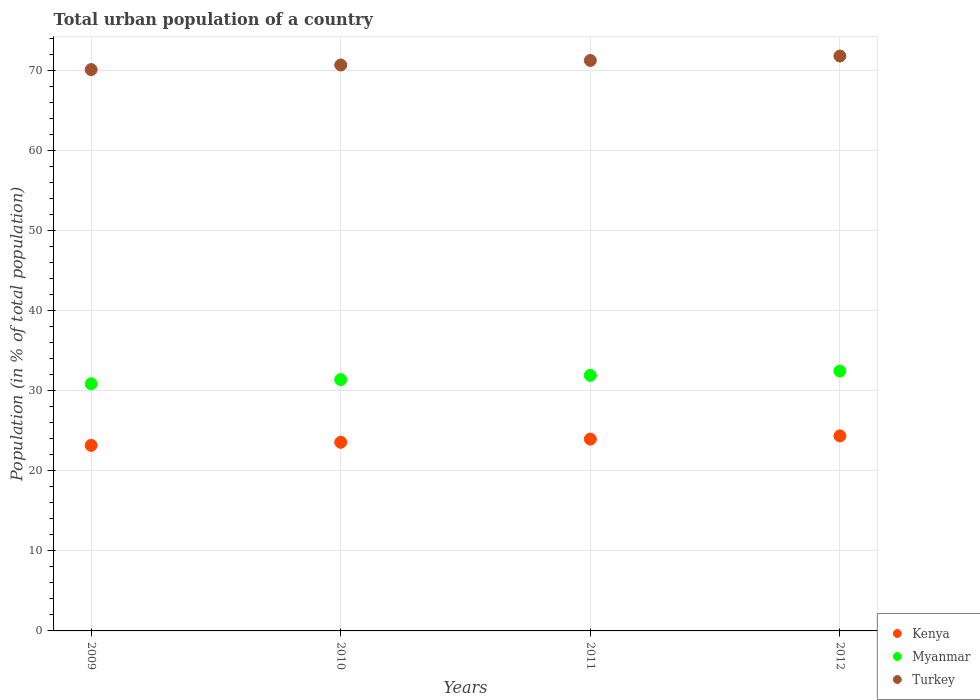How many different coloured dotlines are there?
Your answer should be compact. 3. What is the urban population in Kenya in 2010?
Keep it short and to the point. 23.57. Across all years, what is the maximum urban population in Turkey?
Your answer should be compact. 71.83. Across all years, what is the minimum urban population in Myanmar?
Your answer should be compact. 30.88. In which year was the urban population in Myanmar maximum?
Your answer should be very brief. 2012. In which year was the urban population in Myanmar minimum?
Offer a very short reply. 2009. What is the total urban population in Turkey in the graph?
Your answer should be very brief. 283.97. What is the difference between the urban population in Turkey in 2010 and that in 2011?
Give a very brief answer. -0.57. What is the difference between the urban population in Myanmar in 2009 and the urban population in Turkey in 2012?
Provide a short and direct response. -40.95. What is the average urban population in Kenya per year?
Offer a very short reply. 23.77. In the year 2010, what is the difference between the urban population in Myanmar and urban population in Turkey?
Offer a terse response. -39.31. In how many years, is the urban population in Kenya greater than 62 %?
Provide a short and direct response. 0. What is the ratio of the urban population in Turkey in 2010 to that in 2011?
Provide a succinct answer. 0.99. What is the difference between the highest and the second highest urban population in Turkey?
Ensure brevity in your answer.  0.55. What is the difference between the highest and the lowest urban population in Turkey?
Provide a short and direct response. 1.69. Is it the case that in every year, the sum of the urban population in Kenya and urban population in Turkey  is greater than the urban population in Myanmar?
Give a very brief answer. Yes. Does the urban population in Myanmar monotonically increase over the years?
Provide a short and direct response. Yes. How many years are there in the graph?
Make the answer very short. 4. What is the difference between two consecutive major ticks on the Y-axis?
Provide a succinct answer. 10. Are the values on the major ticks of Y-axis written in scientific E-notation?
Give a very brief answer. No. Does the graph contain any zero values?
Offer a terse response. No. How many legend labels are there?
Make the answer very short. 3. What is the title of the graph?
Offer a very short reply. Total urban population of a country. Does "Djibouti" appear as one of the legend labels in the graph?
Your answer should be compact. No. What is the label or title of the X-axis?
Your answer should be compact. Years. What is the label or title of the Y-axis?
Your response must be concise. Population (in % of total population). What is the Population (in % of total population) of Kenya in 2009?
Provide a succinct answer. 23.18. What is the Population (in % of total population) in Myanmar in 2009?
Offer a terse response. 30.88. What is the Population (in % of total population) in Turkey in 2009?
Your response must be concise. 70.14. What is the Population (in % of total population) of Kenya in 2010?
Provide a succinct answer. 23.57. What is the Population (in % of total population) in Myanmar in 2010?
Offer a very short reply. 31.41. What is the Population (in % of total population) in Turkey in 2010?
Keep it short and to the point. 70.72. What is the Population (in % of total population) in Kenya in 2011?
Give a very brief answer. 23.97. What is the Population (in % of total population) in Myanmar in 2011?
Make the answer very short. 31.93. What is the Population (in % of total population) in Turkey in 2011?
Make the answer very short. 71.28. What is the Population (in % of total population) in Kenya in 2012?
Your answer should be compact. 24.37. What is the Population (in % of total population) in Myanmar in 2012?
Provide a short and direct response. 32.47. What is the Population (in % of total population) of Turkey in 2012?
Your answer should be compact. 71.83. Across all years, what is the maximum Population (in % of total population) in Kenya?
Ensure brevity in your answer.  24.37. Across all years, what is the maximum Population (in % of total population) of Myanmar?
Give a very brief answer. 32.47. Across all years, what is the maximum Population (in % of total population) of Turkey?
Offer a very short reply. 71.83. Across all years, what is the minimum Population (in % of total population) of Kenya?
Provide a short and direct response. 23.18. Across all years, what is the minimum Population (in % of total population) in Myanmar?
Offer a terse response. 30.88. Across all years, what is the minimum Population (in % of total population) of Turkey?
Offer a terse response. 70.14. What is the total Population (in % of total population) of Kenya in the graph?
Offer a very short reply. 95.09. What is the total Population (in % of total population) in Myanmar in the graph?
Offer a terse response. 126.69. What is the total Population (in % of total population) of Turkey in the graph?
Provide a succinct answer. 283.97. What is the difference between the Population (in % of total population) of Kenya in 2009 and that in 2010?
Your answer should be very brief. -0.39. What is the difference between the Population (in % of total population) in Myanmar in 2009 and that in 2010?
Your answer should be compact. -0.52. What is the difference between the Population (in % of total population) of Turkey in 2009 and that in 2010?
Your response must be concise. -0.57. What is the difference between the Population (in % of total population) in Kenya in 2009 and that in 2011?
Give a very brief answer. -0.78. What is the difference between the Population (in % of total population) of Myanmar in 2009 and that in 2011?
Make the answer very short. -1.05. What is the difference between the Population (in % of total population) of Turkey in 2009 and that in 2011?
Keep it short and to the point. -1.14. What is the difference between the Population (in % of total population) in Kenya in 2009 and that in 2012?
Keep it short and to the point. -1.19. What is the difference between the Population (in % of total population) of Myanmar in 2009 and that in 2012?
Your answer should be compact. -1.59. What is the difference between the Population (in % of total population) in Turkey in 2009 and that in 2012?
Offer a terse response. -1.69. What is the difference between the Population (in % of total population) of Kenya in 2010 and that in 2011?
Offer a very short reply. -0.4. What is the difference between the Population (in % of total population) in Myanmar in 2010 and that in 2011?
Your answer should be very brief. -0.53. What is the difference between the Population (in % of total population) in Turkey in 2010 and that in 2011?
Make the answer very short. -0.57. What is the difference between the Population (in % of total population) in Kenya in 2010 and that in 2012?
Offer a very short reply. -0.8. What is the difference between the Population (in % of total population) of Myanmar in 2010 and that in 2012?
Offer a very short reply. -1.06. What is the difference between the Population (in % of total population) in Turkey in 2010 and that in 2012?
Provide a succinct answer. -1.12. What is the difference between the Population (in % of total population) of Kenya in 2011 and that in 2012?
Provide a short and direct response. -0.4. What is the difference between the Population (in % of total population) of Myanmar in 2011 and that in 2012?
Your response must be concise. -0.53. What is the difference between the Population (in % of total population) of Turkey in 2011 and that in 2012?
Ensure brevity in your answer.  -0.55. What is the difference between the Population (in % of total population) in Kenya in 2009 and the Population (in % of total population) in Myanmar in 2010?
Your answer should be very brief. -8.22. What is the difference between the Population (in % of total population) in Kenya in 2009 and the Population (in % of total population) in Turkey in 2010?
Your answer should be very brief. -47.53. What is the difference between the Population (in % of total population) of Myanmar in 2009 and the Population (in % of total population) of Turkey in 2010?
Provide a succinct answer. -39.83. What is the difference between the Population (in % of total population) in Kenya in 2009 and the Population (in % of total population) in Myanmar in 2011?
Keep it short and to the point. -8.75. What is the difference between the Population (in % of total population) of Kenya in 2009 and the Population (in % of total population) of Turkey in 2011?
Ensure brevity in your answer.  -48.1. What is the difference between the Population (in % of total population) of Myanmar in 2009 and the Population (in % of total population) of Turkey in 2011?
Ensure brevity in your answer.  -40.4. What is the difference between the Population (in % of total population) in Kenya in 2009 and the Population (in % of total population) in Myanmar in 2012?
Provide a short and direct response. -9.29. What is the difference between the Population (in % of total population) in Kenya in 2009 and the Population (in % of total population) in Turkey in 2012?
Make the answer very short. -48.65. What is the difference between the Population (in % of total population) of Myanmar in 2009 and the Population (in % of total population) of Turkey in 2012?
Offer a terse response. -40.95. What is the difference between the Population (in % of total population) of Kenya in 2010 and the Population (in % of total population) of Myanmar in 2011?
Give a very brief answer. -8.36. What is the difference between the Population (in % of total population) of Kenya in 2010 and the Population (in % of total population) of Turkey in 2011?
Make the answer very short. -47.71. What is the difference between the Population (in % of total population) in Myanmar in 2010 and the Population (in % of total population) in Turkey in 2011?
Your answer should be very brief. -39.88. What is the difference between the Population (in % of total population) in Kenya in 2010 and the Population (in % of total population) in Myanmar in 2012?
Give a very brief answer. -8.9. What is the difference between the Population (in % of total population) of Kenya in 2010 and the Population (in % of total population) of Turkey in 2012?
Make the answer very short. -48.26. What is the difference between the Population (in % of total population) of Myanmar in 2010 and the Population (in % of total population) of Turkey in 2012?
Offer a very short reply. -40.43. What is the difference between the Population (in % of total population) of Kenya in 2011 and the Population (in % of total population) of Myanmar in 2012?
Offer a very short reply. -8.5. What is the difference between the Population (in % of total population) in Kenya in 2011 and the Population (in % of total population) in Turkey in 2012?
Ensure brevity in your answer.  -47.87. What is the difference between the Population (in % of total population) of Myanmar in 2011 and the Population (in % of total population) of Turkey in 2012?
Make the answer very short. -39.9. What is the average Population (in % of total population) of Kenya per year?
Provide a succinct answer. 23.77. What is the average Population (in % of total population) in Myanmar per year?
Your response must be concise. 31.67. What is the average Population (in % of total population) in Turkey per year?
Keep it short and to the point. 70.99. In the year 2009, what is the difference between the Population (in % of total population) in Kenya and Population (in % of total population) in Myanmar?
Offer a terse response. -7.7. In the year 2009, what is the difference between the Population (in % of total population) in Kenya and Population (in % of total population) in Turkey?
Offer a very short reply. -46.96. In the year 2009, what is the difference between the Population (in % of total population) of Myanmar and Population (in % of total population) of Turkey?
Make the answer very short. -39.26. In the year 2010, what is the difference between the Population (in % of total population) in Kenya and Population (in % of total population) in Myanmar?
Provide a short and direct response. -7.83. In the year 2010, what is the difference between the Population (in % of total population) of Kenya and Population (in % of total population) of Turkey?
Ensure brevity in your answer.  -47.14. In the year 2010, what is the difference between the Population (in % of total population) in Myanmar and Population (in % of total population) in Turkey?
Offer a very short reply. -39.31. In the year 2011, what is the difference between the Population (in % of total population) in Kenya and Population (in % of total population) in Myanmar?
Offer a terse response. -7.97. In the year 2011, what is the difference between the Population (in % of total population) in Kenya and Population (in % of total population) in Turkey?
Make the answer very short. -47.31. In the year 2011, what is the difference between the Population (in % of total population) of Myanmar and Population (in % of total population) of Turkey?
Ensure brevity in your answer.  -39.35. In the year 2012, what is the difference between the Population (in % of total population) in Kenya and Population (in % of total population) in Myanmar?
Your answer should be very brief. -8.1. In the year 2012, what is the difference between the Population (in % of total population) of Kenya and Population (in % of total population) of Turkey?
Make the answer very short. -47.46. In the year 2012, what is the difference between the Population (in % of total population) in Myanmar and Population (in % of total population) in Turkey?
Provide a succinct answer. -39.37. What is the ratio of the Population (in % of total population) in Kenya in 2009 to that in 2010?
Provide a short and direct response. 0.98. What is the ratio of the Population (in % of total population) of Myanmar in 2009 to that in 2010?
Make the answer very short. 0.98. What is the ratio of the Population (in % of total population) of Turkey in 2009 to that in 2010?
Make the answer very short. 0.99. What is the ratio of the Population (in % of total population) in Kenya in 2009 to that in 2011?
Keep it short and to the point. 0.97. What is the ratio of the Population (in % of total population) of Turkey in 2009 to that in 2011?
Offer a terse response. 0.98. What is the ratio of the Population (in % of total population) of Kenya in 2009 to that in 2012?
Provide a succinct answer. 0.95. What is the ratio of the Population (in % of total population) in Myanmar in 2009 to that in 2012?
Offer a very short reply. 0.95. What is the ratio of the Population (in % of total population) in Turkey in 2009 to that in 2012?
Provide a succinct answer. 0.98. What is the ratio of the Population (in % of total population) in Kenya in 2010 to that in 2011?
Give a very brief answer. 0.98. What is the ratio of the Population (in % of total population) in Myanmar in 2010 to that in 2011?
Make the answer very short. 0.98. What is the ratio of the Population (in % of total population) of Turkey in 2010 to that in 2011?
Offer a very short reply. 0.99. What is the ratio of the Population (in % of total population) of Kenya in 2010 to that in 2012?
Your response must be concise. 0.97. What is the ratio of the Population (in % of total population) of Myanmar in 2010 to that in 2012?
Offer a very short reply. 0.97. What is the ratio of the Population (in % of total population) in Turkey in 2010 to that in 2012?
Offer a very short reply. 0.98. What is the ratio of the Population (in % of total population) of Kenya in 2011 to that in 2012?
Your answer should be compact. 0.98. What is the ratio of the Population (in % of total population) in Myanmar in 2011 to that in 2012?
Provide a succinct answer. 0.98. What is the ratio of the Population (in % of total population) in Turkey in 2011 to that in 2012?
Ensure brevity in your answer.  0.99. What is the difference between the highest and the second highest Population (in % of total population) of Kenya?
Give a very brief answer. 0.4. What is the difference between the highest and the second highest Population (in % of total population) in Myanmar?
Your answer should be compact. 0.53. What is the difference between the highest and the second highest Population (in % of total population) of Turkey?
Provide a short and direct response. 0.55. What is the difference between the highest and the lowest Population (in % of total population) of Kenya?
Your answer should be very brief. 1.19. What is the difference between the highest and the lowest Population (in % of total population) in Myanmar?
Offer a very short reply. 1.59. What is the difference between the highest and the lowest Population (in % of total population) in Turkey?
Make the answer very short. 1.69. 